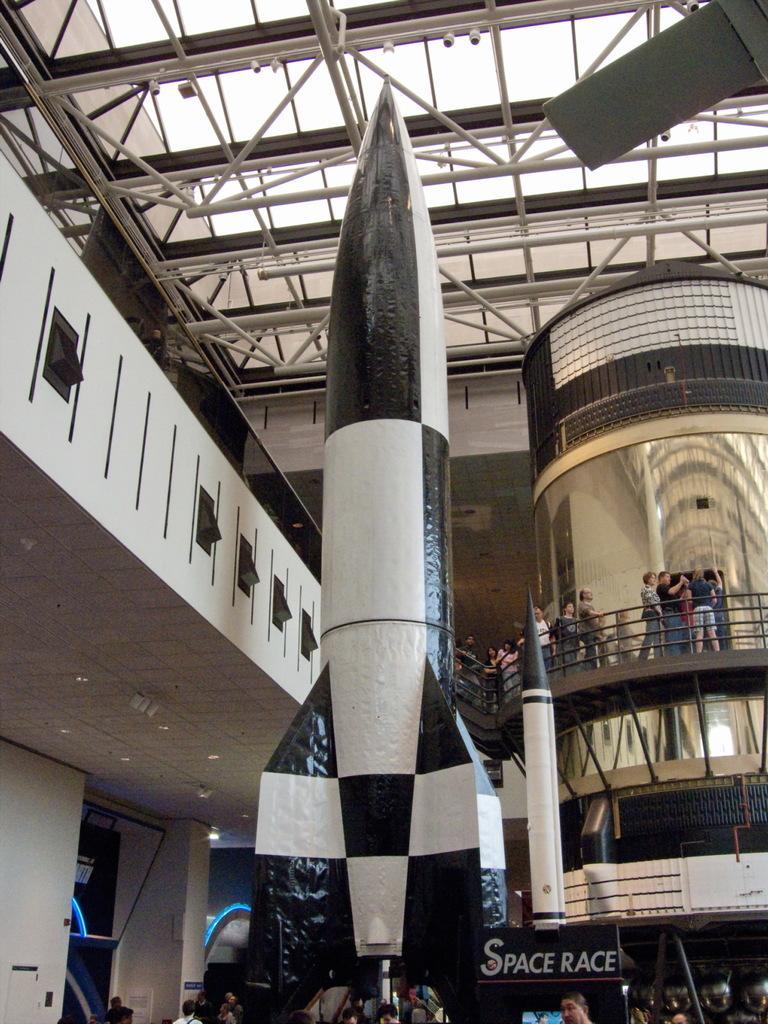How many people are in the group visible in the image? There is a group of people in the image, but the exact number is not specified. What type of objects can be seen in the image? There are rockets, a banner, posters, lights, and rods in the image. What are the people in the group doing? Some people are standing in the image, but their actions are not described. What can be used to convey information or promote something in the image? The banner and posters in the image can be used for conveying information or promoting something. How far away is the hydrant from the group of people in the image? There is no hydrant present in the image, so it is not possible to determine its distance from the group of people. 